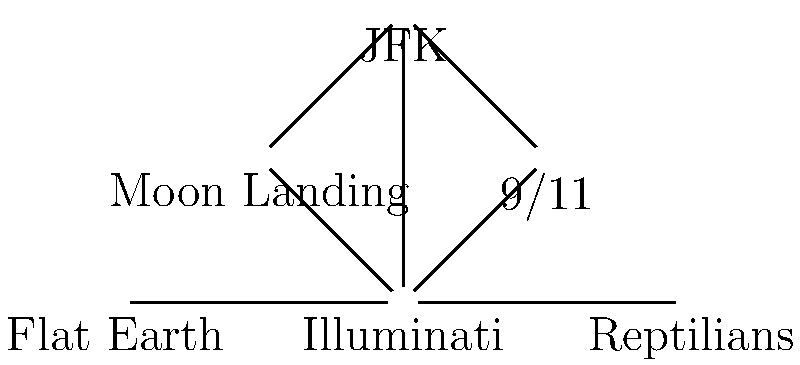Based on the network graph of conspiracy theories, which theory appears to be the most central or connected to others? To determine the most central or connected conspiracy theory, we need to analyze the connections (edges) between the different theories (nodes) in the network graph. Let's count the number of connections for each theory:

1. Illuminati: Connected to 9/11, Moon Landing, JFK, Flat Earth, and Reptilians (5 connections)
2. 9/11: Connected to Illuminati and JFK (2 connections)
3. Moon Landing: Connected to Illuminati and JFK (2 connections)
4. JFK: Connected to Illuminati, 9/11, and Moon Landing (3 connections)
5. Flat Earth: Connected to Illuminati and Reptilians (2 connections)
6. Reptilians: Connected to Illuminati and Flat Earth (2 connections)

The theory with the most connections is the Illuminati, with 5 connections to other theories. This suggests that the Illuminati conspiracy theory is the most central or connected in this network of conspiracy theories.
Answer: Illuminati 